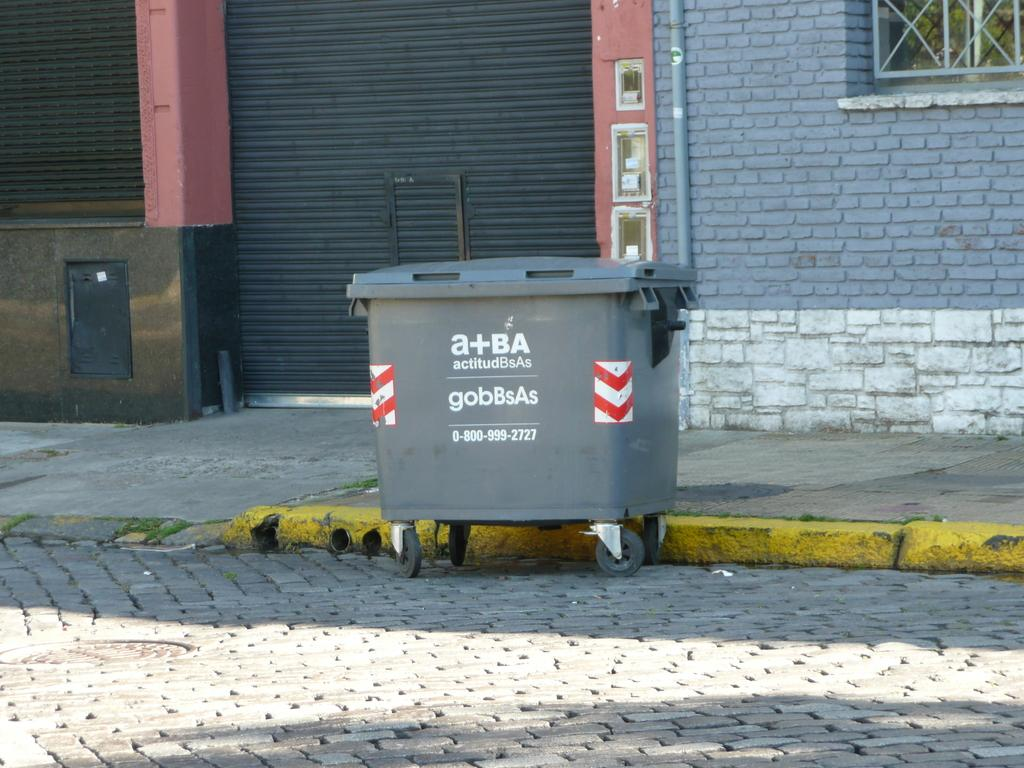What is the main object in the center of the image? There is a garbage box in the center of the image. What can be seen in the background of the image? There is a window, a pipe, shutters, and a wall in the background of the image. What color is the paint on the house in the image? There is no house present in the image, only a garbage box and various elements in the background. 